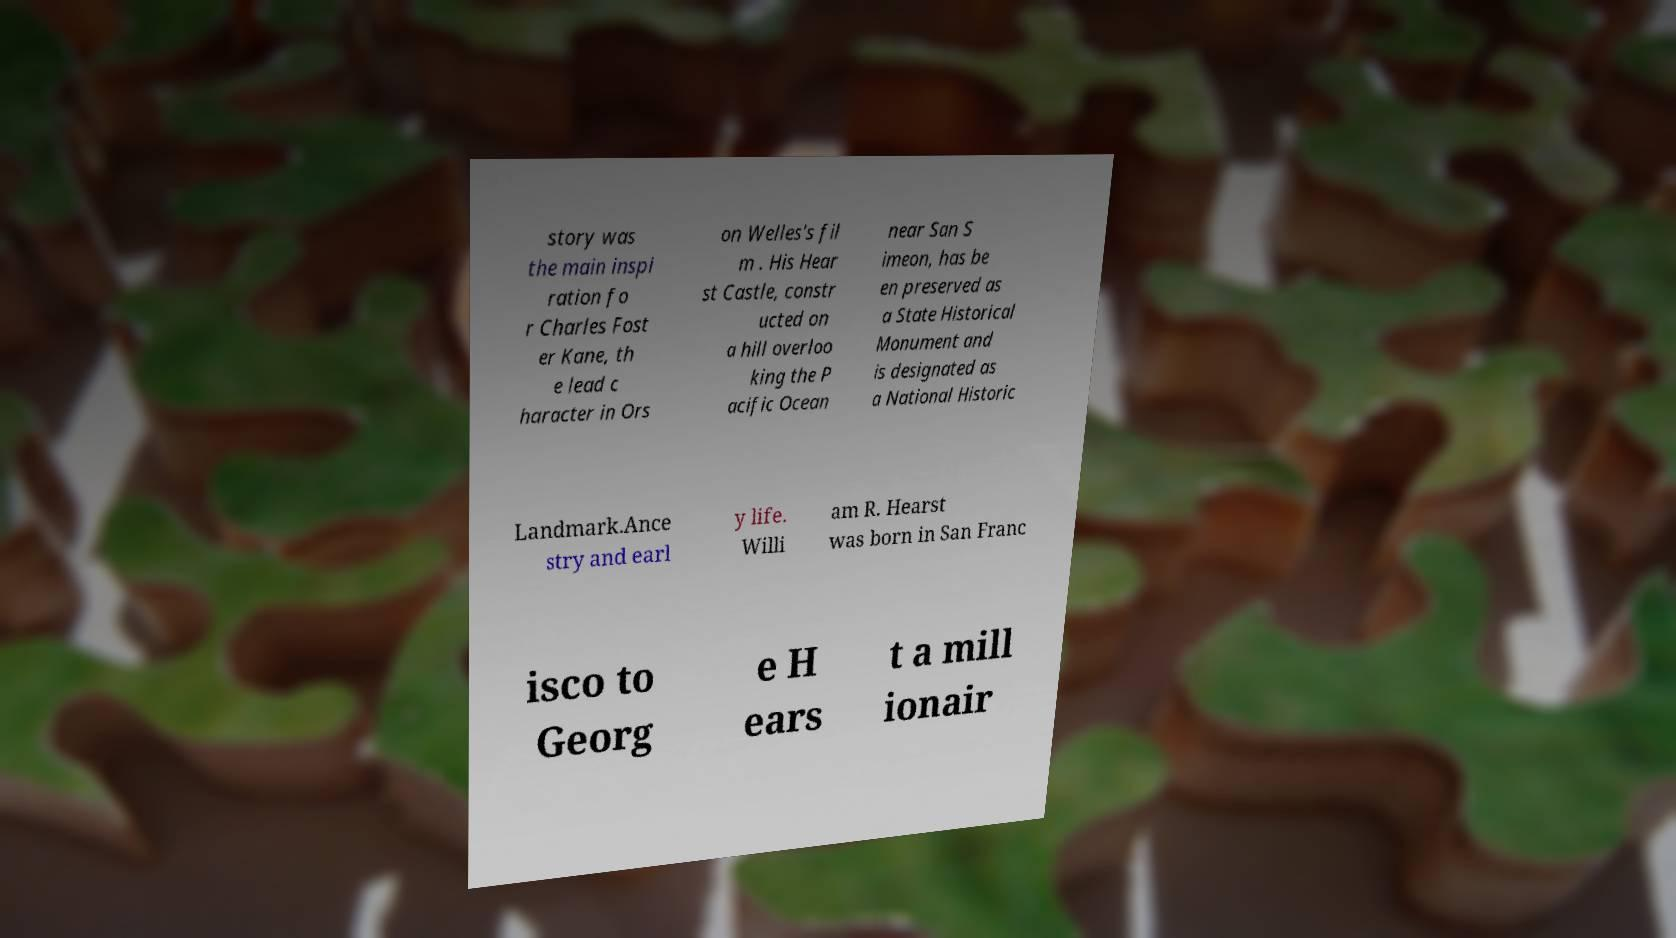Could you extract and type out the text from this image? story was the main inspi ration fo r Charles Fost er Kane, th e lead c haracter in Ors on Welles's fil m . His Hear st Castle, constr ucted on a hill overloo king the P acific Ocean near San S imeon, has be en preserved as a State Historical Monument and is designated as a National Historic Landmark.Ance stry and earl y life. Willi am R. Hearst was born in San Franc isco to Georg e H ears t a mill ionair 